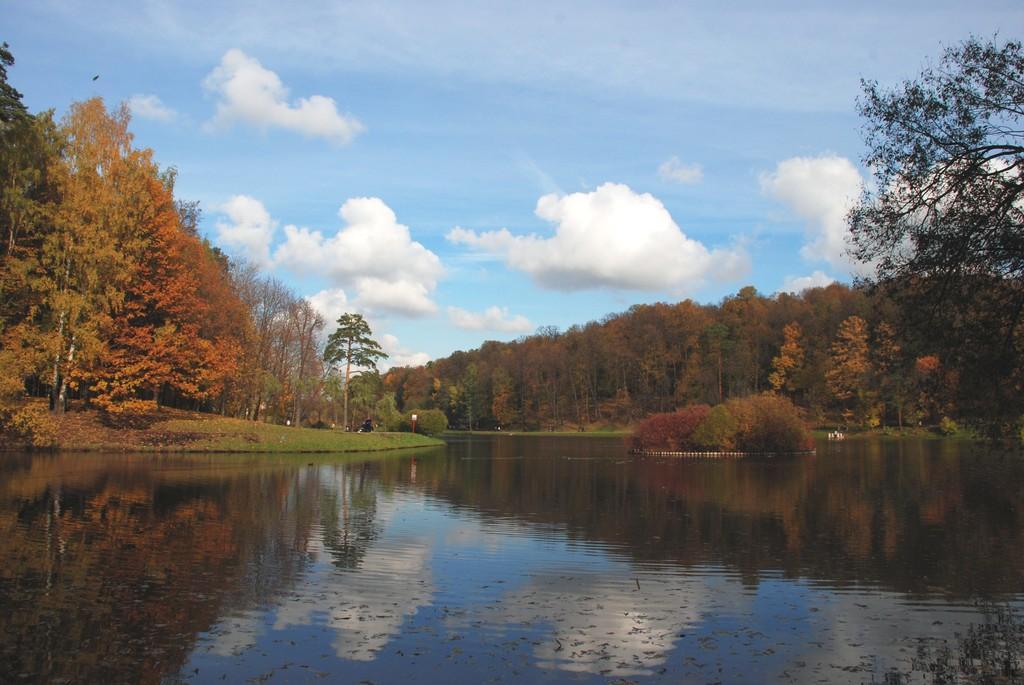How would you summarize this image in a sentence or two? In this picture we can see the water, trees, some objects and in the background we can see the sky with clouds. 